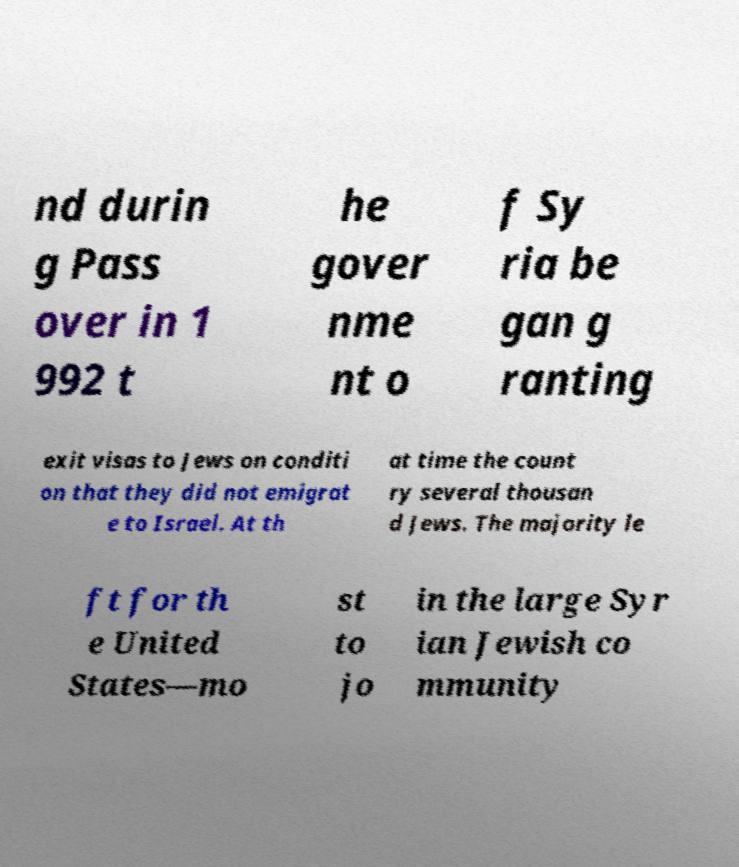Could you assist in decoding the text presented in this image and type it out clearly? nd durin g Pass over in 1 992 t he gover nme nt o f Sy ria be gan g ranting exit visas to Jews on conditi on that they did not emigrat e to Israel. At th at time the count ry several thousan d Jews. The majority le ft for th e United States—mo st to jo in the large Syr ian Jewish co mmunity 